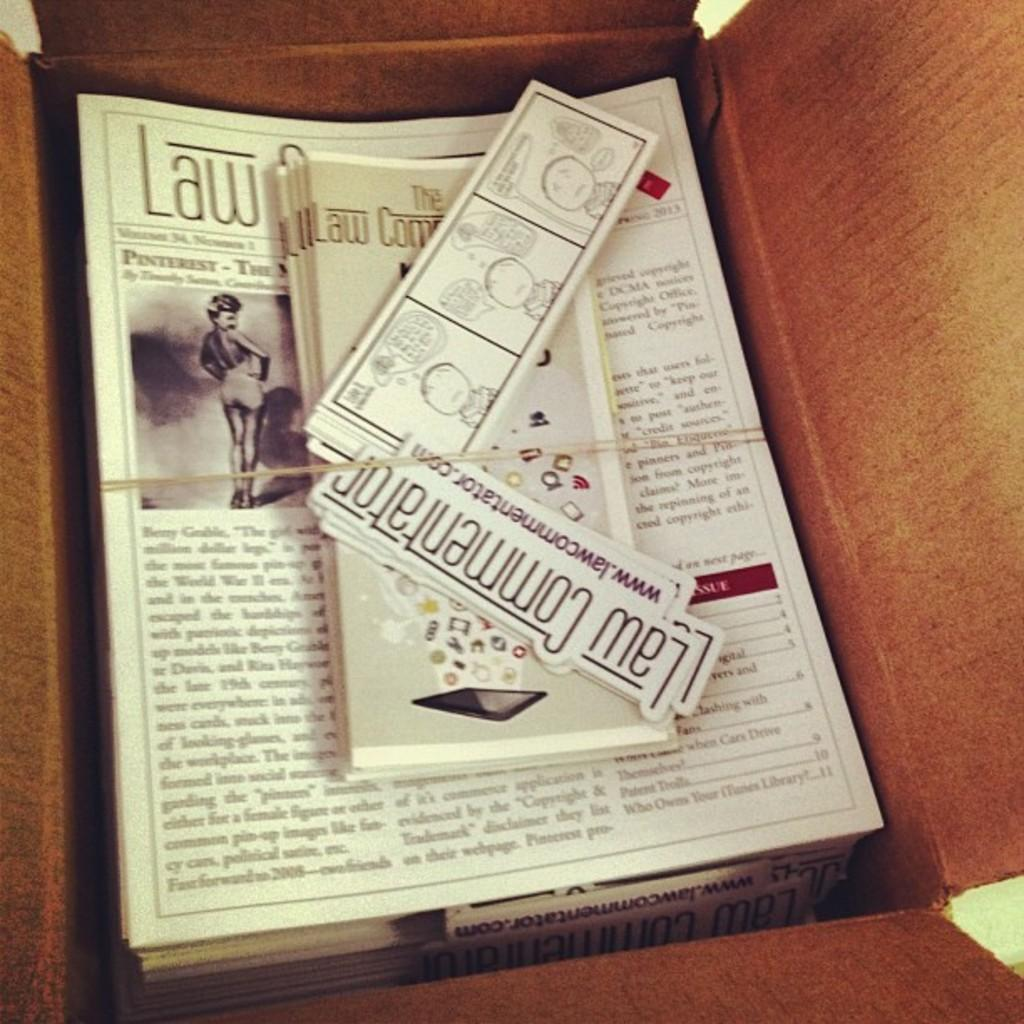Provide a one-sentence caption for the provided image. Looking down into an opened box containing magazines, flyers and signs with the words Law Commentator on them. 